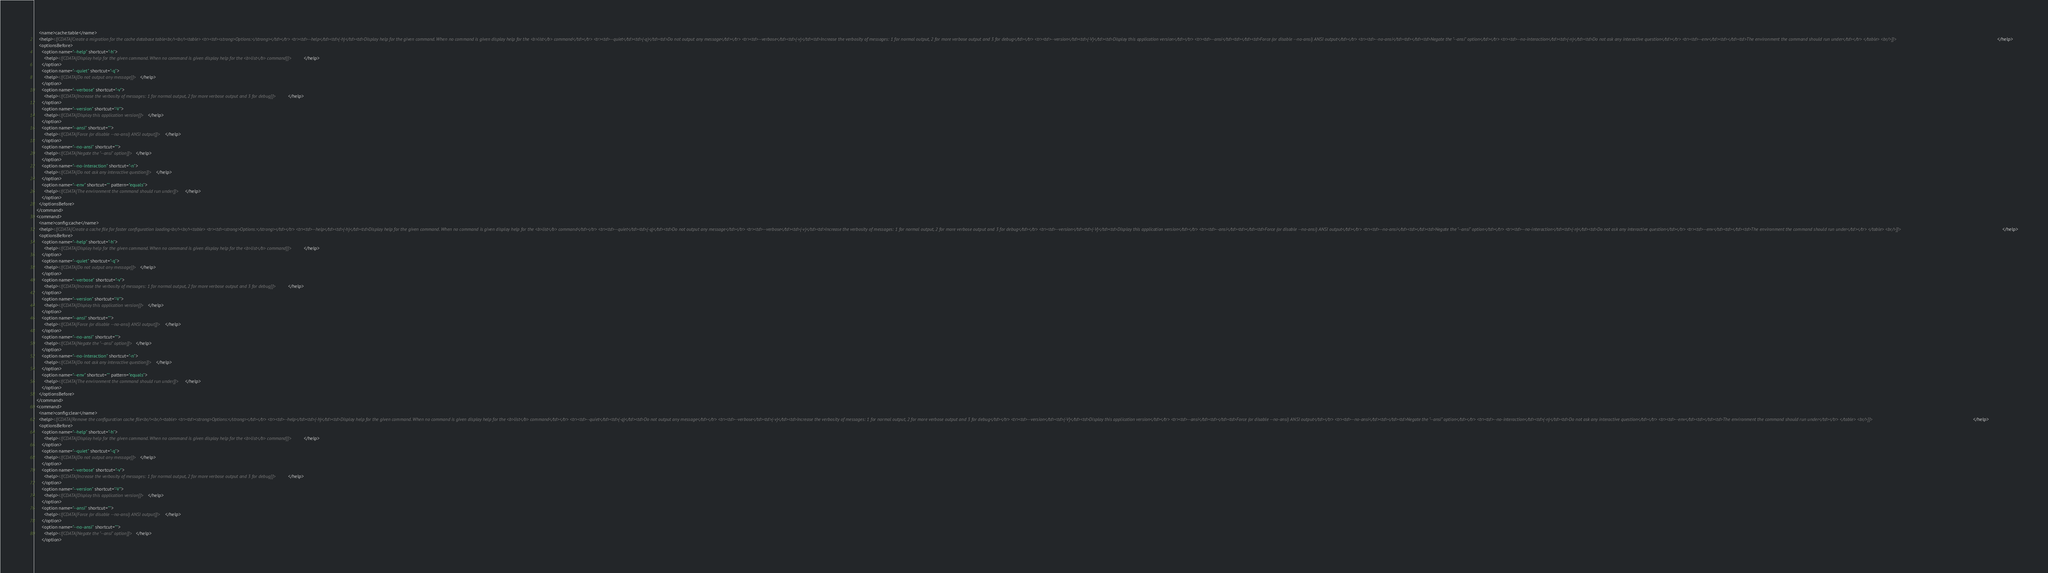Convert code to text. <code><loc_0><loc_0><loc_500><loc_500><_XML_>    <name>cache:table</name>
    <help><![CDATA[Create a migration for the cache database table<br/><br/><table> <tr><td><strong>Options:</strong></td></tr> <tr><td>--help</td><td>(-h)</td><td>Display help for the given command. When no command is given display help for the <b>list</b> command</td></tr> <tr><td>--quiet</td><td>(-q)</td><td>Do not output any message</td></tr> <tr><td>--verbose</td><td>(-v)</td><td>Increase the verbosity of messages: 1 for normal output, 2 for more verbose output and 3 for debug</td></tr> <tr><td>--version</td><td>(-V)</td><td>Display this application version</td></tr> <tr><td>--ansi</td><td></td><td>Force (or disable --no-ansi) ANSI output</td></tr> <tr><td>--no-ansi</td><td></td><td>Negate the "--ansi" option</td></tr> <tr><td>--no-interaction</td><td>(-n)</td><td>Do not ask any interactive question</td></tr> <tr><td>--env</td><td></td><td>The environment the command should run under</td></tr> </table> <br/>]]></help>
    <optionsBefore>
      <option name="--help" shortcut="-h">
        <help><![CDATA[Display help for the given command. When no command is given display help for the <b>list</b> command]]></help>
      </option>
      <option name="--quiet" shortcut="-q">
        <help><![CDATA[Do not output any message]]></help>
      </option>
      <option name="--verbose" shortcut="-v">
        <help><![CDATA[Increase the verbosity of messages: 1 for normal output, 2 for more verbose output and 3 for debug]]></help>
      </option>
      <option name="--version" shortcut="-V">
        <help><![CDATA[Display this application version]]></help>
      </option>
      <option name="--ansi" shortcut="">
        <help><![CDATA[Force (or disable --no-ansi) ANSI output]]></help>
      </option>
      <option name="--no-ansi" shortcut="">
        <help><![CDATA[Negate the "--ansi" option]]></help>
      </option>
      <option name="--no-interaction" shortcut="-n">
        <help><![CDATA[Do not ask any interactive question]]></help>
      </option>
      <option name="--env" shortcut="" pattern="equals">
        <help><![CDATA[The environment the command should run under]]></help>
      </option>
    </optionsBefore>
  </command>
  <command>
    <name>config:cache</name>
    <help><![CDATA[Create a cache file for faster configuration loading<br/><br/><table> <tr><td><strong>Options:</strong></td></tr> <tr><td>--help</td><td>(-h)</td><td>Display help for the given command. When no command is given display help for the <b>list</b> command</td></tr> <tr><td>--quiet</td><td>(-q)</td><td>Do not output any message</td></tr> <tr><td>--verbose</td><td>(-v)</td><td>Increase the verbosity of messages: 1 for normal output, 2 for more verbose output and 3 for debug</td></tr> <tr><td>--version</td><td>(-V)</td><td>Display this application version</td></tr> <tr><td>--ansi</td><td></td><td>Force (or disable --no-ansi) ANSI output</td></tr> <tr><td>--no-ansi</td><td></td><td>Negate the "--ansi" option</td></tr> <tr><td>--no-interaction</td><td>(-n)</td><td>Do not ask any interactive question</td></tr> <tr><td>--env</td><td></td><td>The environment the command should run under</td></tr> </table> <br/>]]></help>
    <optionsBefore>
      <option name="--help" shortcut="-h">
        <help><![CDATA[Display help for the given command. When no command is given display help for the <b>list</b> command]]></help>
      </option>
      <option name="--quiet" shortcut="-q">
        <help><![CDATA[Do not output any message]]></help>
      </option>
      <option name="--verbose" shortcut="-v">
        <help><![CDATA[Increase the verbosity of messages: 1 for normal output, 2 for more verbose output and 3 for debug]]></help>
      </option>
      <option name="--version" shortcut="-V">
        <help><![CDATA[Display this application version]]></help>
      </option>
      <option name="--ansi" shortcut="">
        <help><![CDATA[Force (or disable --no-ansi) ANSI output]]></help>
      </option>
      <option name="--no-ansi" shortcut="">
        <help><![CDATA[Negate the "--ansi" option]]></help>
      </option>
      <option name="--no-interaction" shortcut="-n">
        <help><![CDATA[Do not ask any interactive question]]></help>
      </option>
      <option name="--env" shortcut="" pattern="equals">
        <help><![CDATA[The environment the command should run under]]></help>
      </option>
    </optionsBefore>
  </command>
  <command>
    <name>config:clear</name>
    <help><![CDATA[Remove the configuration cache file<br/><br/><table> <tr><td><strong>Options:</strong></td></tr> <tr><td>--help</td><td>(-h)</td><td>Display help for the given command. When no command is given display help for the <b>list</b> command</td></tr> <tr><td>--quiet</td><td>(-q)</td><td>Do not output any message</td></tr> <tr><td>--verbose</td><td>(-v)</td><td>Increase the verbosity of messages: 1 for normal output, 2 for more verbose output and 3 for debug</td></tr> <tr><td>--version</td><td>(-V)</td><td>Display this application version</td></tr> <tr><td>--ansi</td><td></td><td>Force (or disable --no-ansi) ANSI output</td></tr> <tr><td>--no-ansi</td><td></td><td>Negate the "--ansi" option</td></tr> <tr><td>--no-interaction</td><td>(-n)</td><td>Do not ask any interactive question</td></tr> <tr><td>--env</td><td></td><td>The environment the command should run under</td></tr> </table> <br/>]]></help>
    <optionsBefore>
      <option name="--help" shortcut="-h">
        <help><![CDATA[Display help for the given command. When no command is given display help for the <b>list</b> command]]></help>
      </option>
      <option name="--quiet" shortcut="-q">
        <help><![CDATA[Do not output any message]]></help>
      </option>
      <option name="--verbose" shortcut="-v">
        <help><![CDATA[Increase the verbosity of messages: 1 for normal output, 2 for more verbose output and 3 for debug]]></help>
      </option>
      <option name="--version" shortcut="-V">
        <help><![CDATA[Display this application version]]></help>
      </option>
      <option name="--ansi" shortcut="">
        <help><![CDATA[Force (or disable --no-ansi) ANSI output]]></help>
      </option>
      <option name="--no-ansi" shortcut="">
        <help><![CDATA[Negate the "--ansi" option]]></help>
      </option></code> 